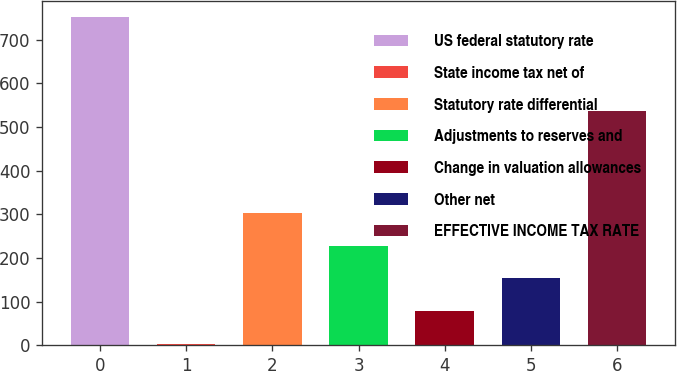<chart> <loc_0><loc_0><loc_500><loc_500><bar_chart><fcel>US federal statutory rate<fcel>State income tax net of<fcel>Statutory rate differential<fcel>Adjustments to reserves and<fcel>Change in valuation allowances<fcel>Other net<fcel>EFFECTIVE INCOME TAX RATE<nl><fcel>751<fcel>4<fcel>302.8<fcel>228.1<fcel>78.7<fcel>153.4<fcel>537<nl></chart> 